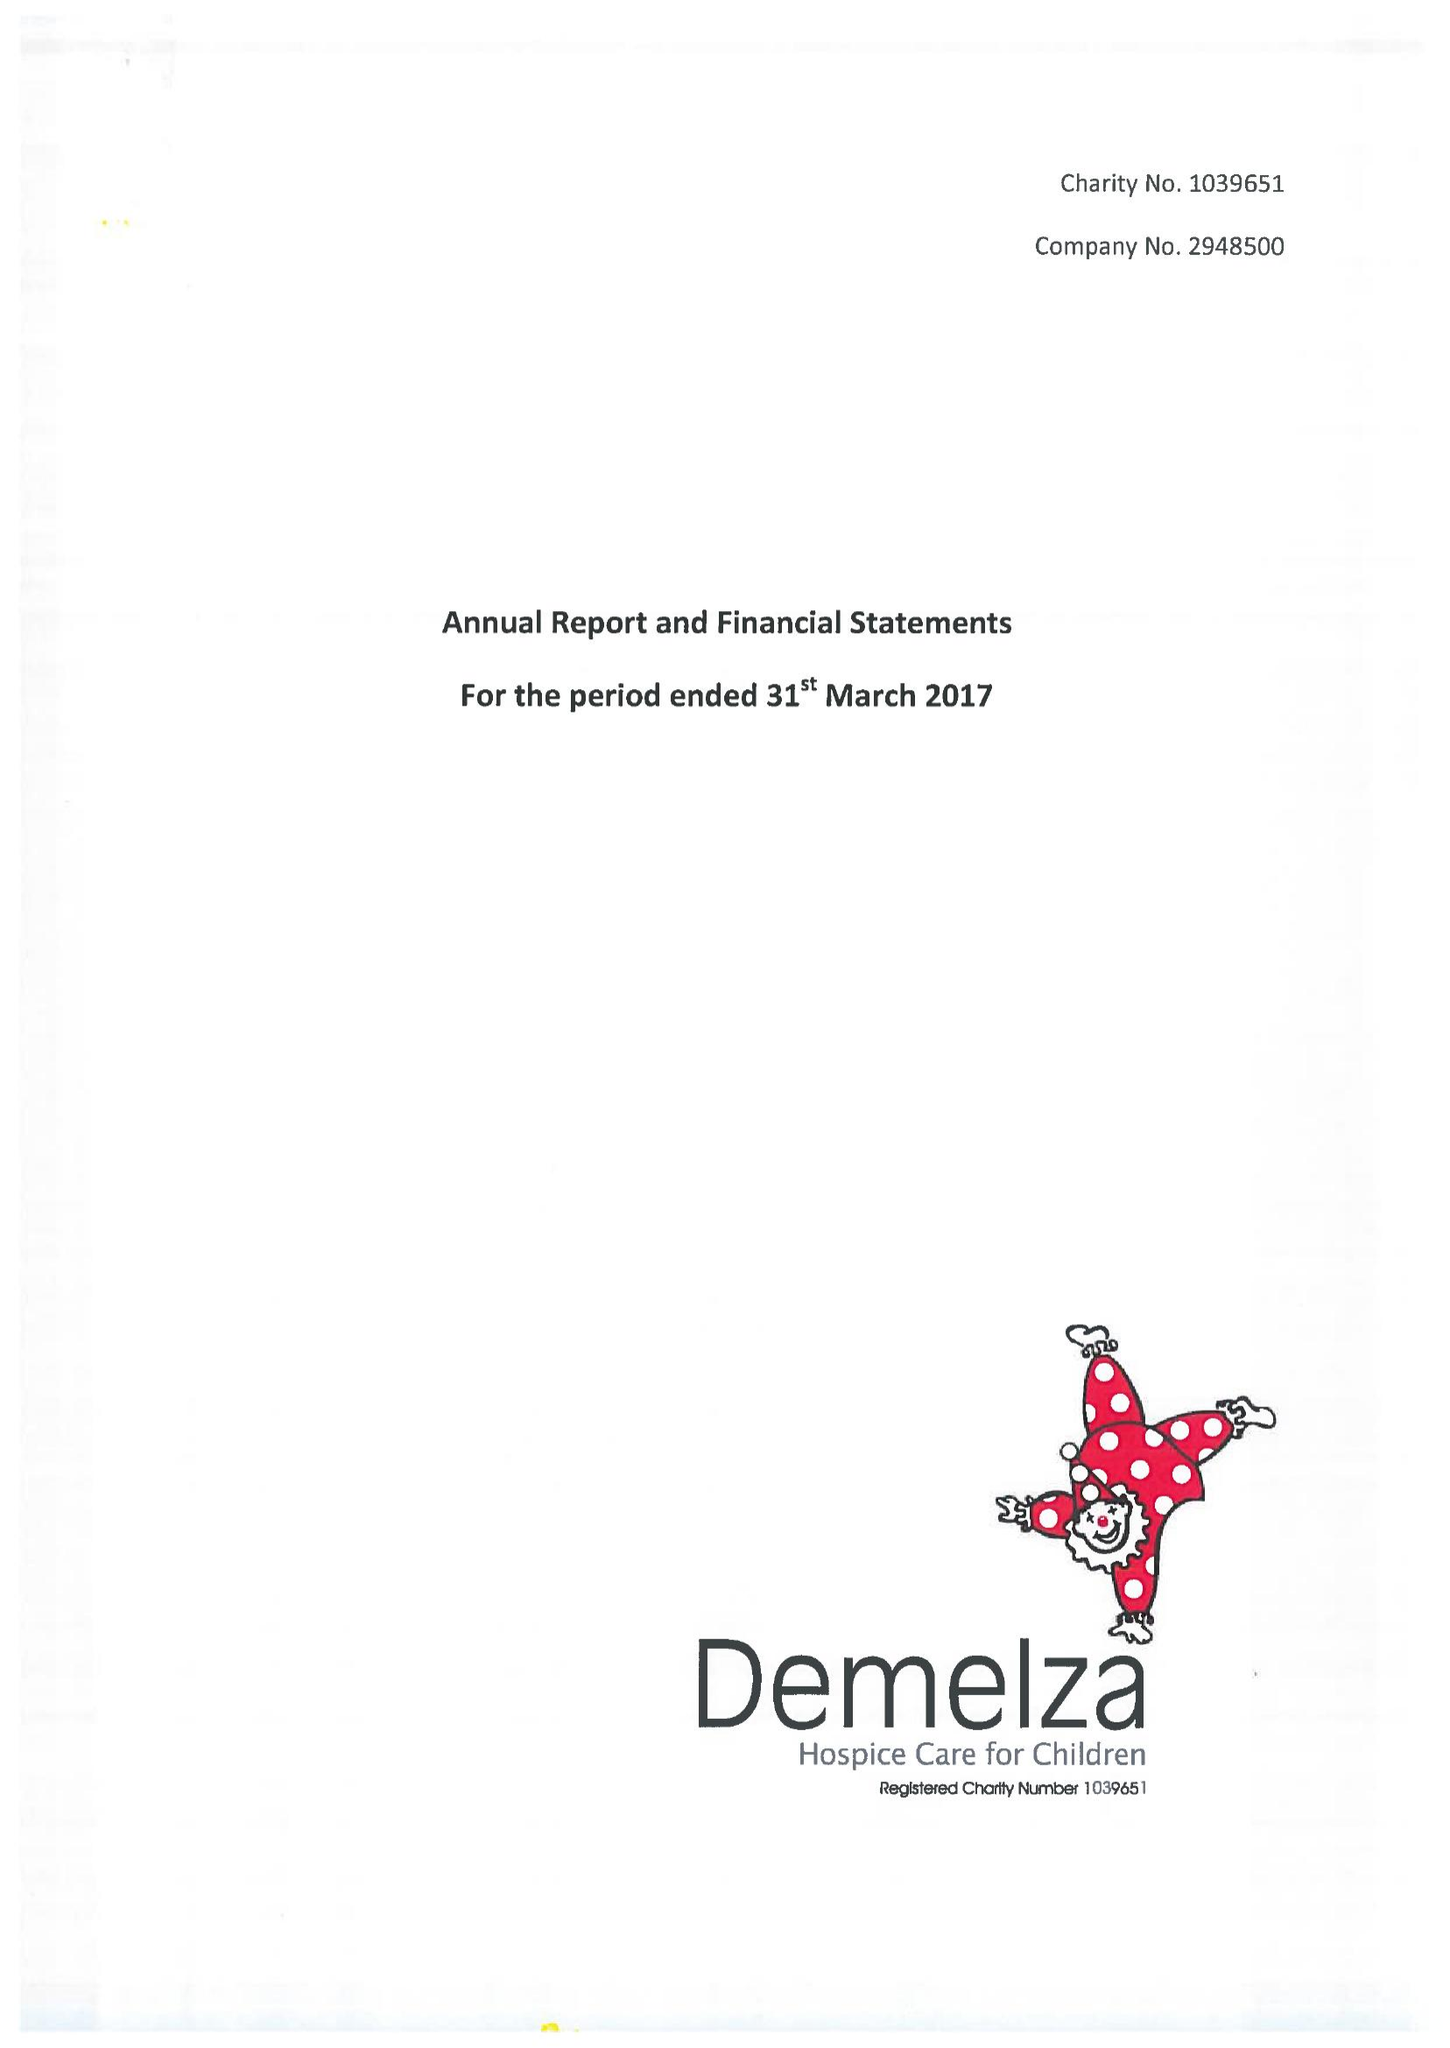What is the value for the address__street_line?
Answer the question using a single word or phrase. ROOK LANE 